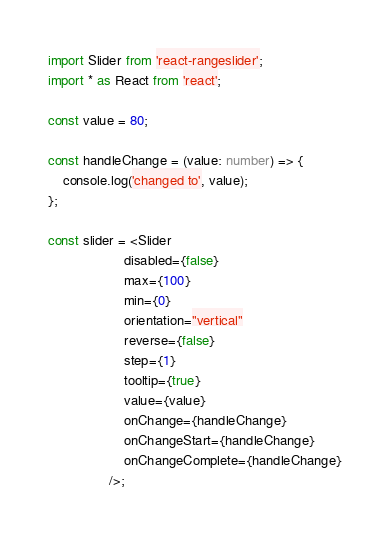<code> <loc_0><loc_0><loc_500><loc_500><_TypeScript_>import Slider from 'react-rangeslider';
import * as React from 'react';

const value = 80;

const handleChange = (value: number) => {
	console.log('changed to', value);
};

const slider = <Slider
					disabled={false}
					max={100}
					min={0}
					orientation="vertical"
					reverse={false}
					step={1}
					tooltip={true}
					value={value}
					onChange={handleChange}
					onChangeStart={handleChange}
					onChangeComplete={handleChange}
				/>;
</code> 